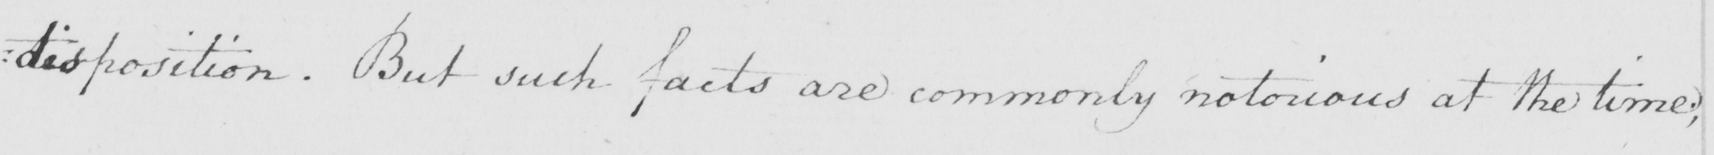Transcribe the text shown in this historical manuscript line. : disposition . But such facts are commonly notorious at the time ; 